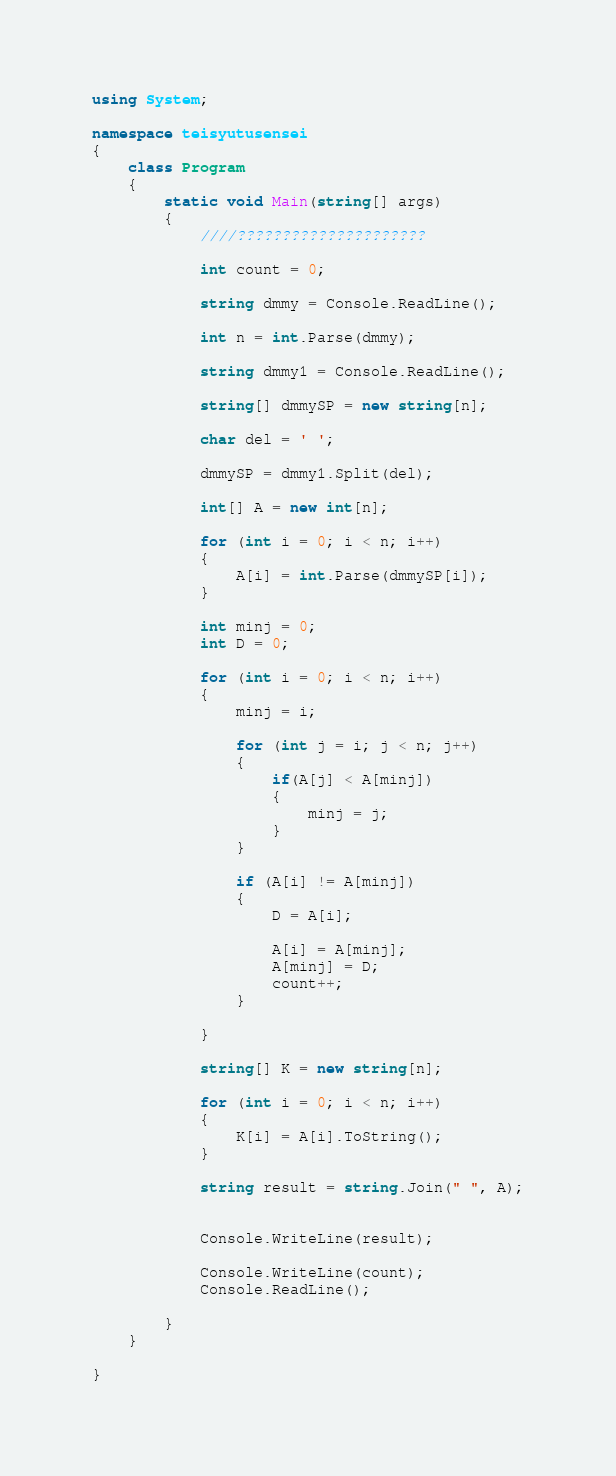Convert code to text. <code><loc_0><loc_0><loc_500><loc_500><_C#_>using System;

namespace teisyutusensei
{
    class Program
    {
        static void Main(string[] args)
        {
            ////?????????????????????

            int count = 0;

            string dmmy = Console.ReadLine();

            int n = int.Parse(dmmy);

            string dmmy1 = Console.ReadLine();

            string[] dmmySP = new string[n];

            char del = ' ';

            dmmySP = dmmy1.Split(del);

            int[] A = new int[n];

            for (int i = 0; i < n; i++)
            {
                A[i] = int.Parse(dmmySP[i]);
            }

            int minj = 0;
            int D = 0;

            for (int i = 0; i < n; i++)
            {
                minj = i;

                for (int j = i; j < n; j++)
                {
                    if(A[j] < A[minj])
                    {
                        minj = j;
                    }
                }

                if (A[i] != A[minj])
                {
                    D = A[i];

                    A[i] = A[minj];
                    A[minj] = D;
                    count++;
                }

            }

            string[] K = new string[n];

            for (int i = 0; i < n; i++)
            {                
                K[i] = A[i].ToString();
            }

            string result = string.Join(" ", A);


            Console.WriteLine(result);

            Console.WriteLine(count);
            Console.ReadLine();

        }
    }

}</code> 